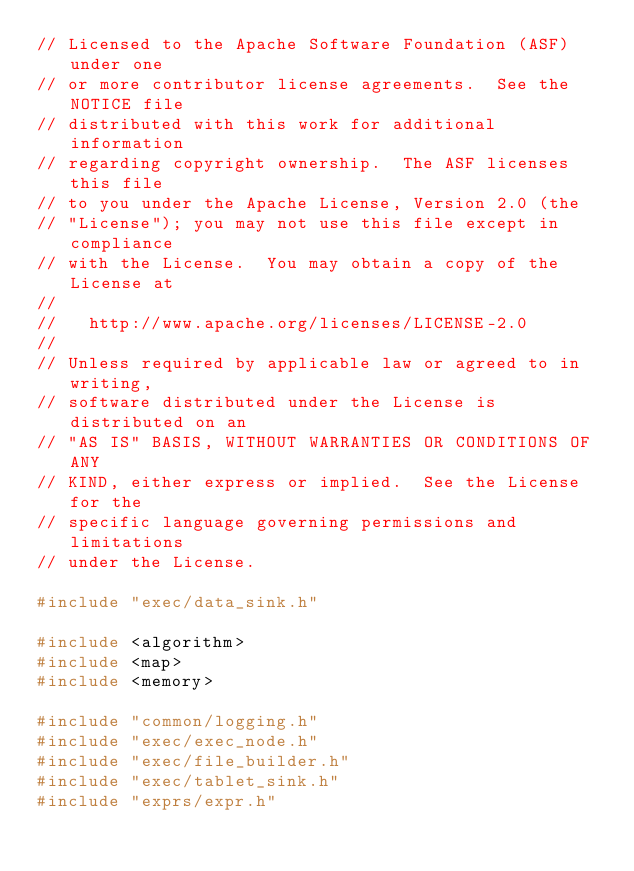Convert code to text. <code><loc_0><loc_0><loc_500><loc_500><_C++_>// Licensed to the Apache Software Foundation (ASF) under one
// or more contributor license agreements.  See the NOTICE file
// distributed with this work for additional information
// regarding copyright ownership.  The ASF licenses this file
// to you under the Apache License, Version 2.0 (the
// "License"); you may not use this file except in compliance
// with the License.  You may obtain a copy of the License at
//
//   http://www.apache.org/licenses/LICENSE-2.0
//
// Unless required by applicable law or agreed to in writing,
// software distributed under the License is distributed on an
// "AS IS" BASIS, WITHOUT WARRANTIES OR CONDITIONS OF ANY
// KIND, either express or implied.  See the License for the
// specific language governing permissions and limitations
// under the License.

#include "exec/data_sink.h"

#include <algorithm>
#include <map>
#include <memory>

#include "common/logging.h"
#include "exec/exec_node.h"
#include "exec/file_builder.h"
#include "exec/tablet_sink.h"
#include "exprs/expr.h"</code> 